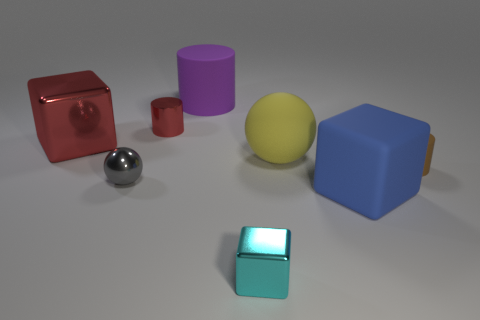There is a thing that is the same color as the shiny cylinder; what is its material?
Provide a succinct answer. Metal. What is the shape of the tiny thing that is made of the same material as the yellow ball?
Keep it short and to the point. Cylinder. There is a ball that is to the right of the small cyan object; is it the same size as the block behind the brown thing?
Offer a very short reply. Yes. Are there more red cylinders on the right side of the big blue thing than big yellow spheres in front of the brown cylinder?
Ensure brevity in your answer.  No. How many other things are there of the same color as the large metal cube?
Make the answer very short. 1. Does the large cylinder have the same color as the tiny shiny thing to the right of the small red shiny cylinder?
Offer a very short reply. No. There is a tiny cyan object that is in front of the purple rubber object; what number of large spheres are in front of it?
Make the answer very short. 0. The red object in front of the small cylinder behind the tiny cylinder that is right of the small cyan metallic thing is made of what material?
Your answer should be compact. Metal. What is the large thing that is on the left side of the yellow sphere and on the right side of the small gray metallic sphere made of?
Keep it short and to the point. Rubber. How big is the red object in front of the tiny cylinder that is left of the small shiny block?
Offer a very short reply. Large. 